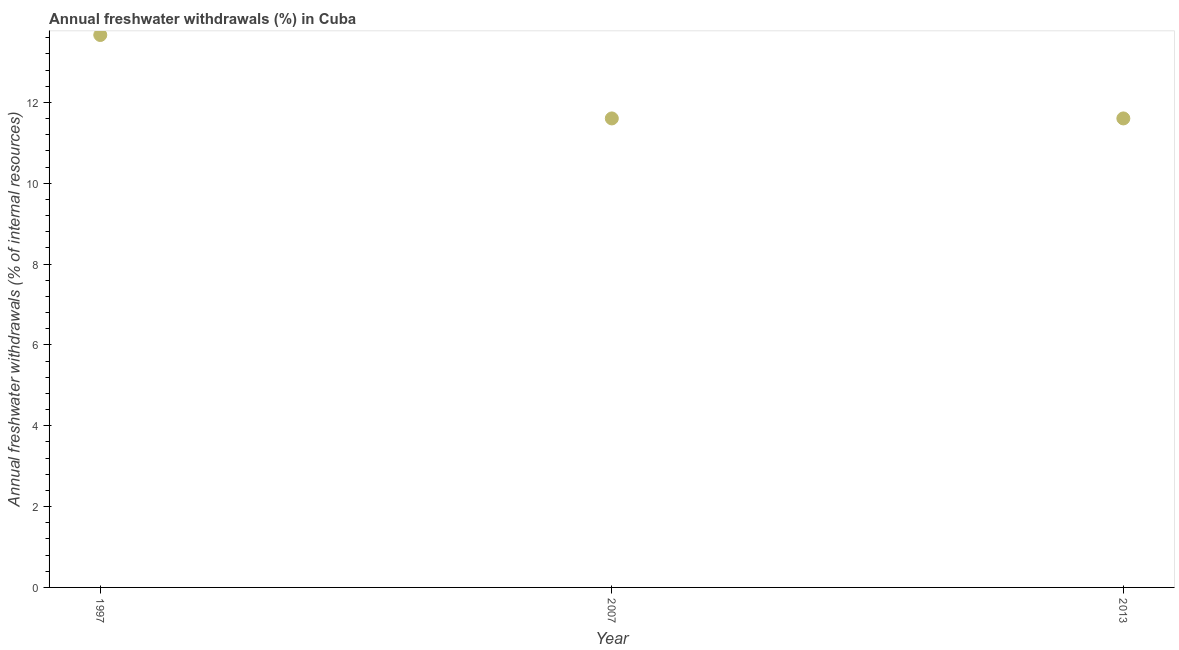What is the annual freshwater withdrawals in 2013?
Your answer should be very brief. 11.61. Across all years, what is the maximum annual freshwater withdrawals?
Give a very brief answer. 13.67. Across all years, what is the minimum annual freshwater withdrawals?
Keep it short and to the point. 11.61. In which year was the annual freshwater withdrawals maximum?
Your answer should be compact. 1997. In which year was the annual freshwater withdrawals minimum?
Provide a short and direct response. 2007. What is the sum of the annual freshwater withdrawals?
Make the answer very short. 36.88. What is the difference between the annual freshwater withdrawals in 2007 and 2013?
Make the answer very short. 0. What is the average annual freshwater withdrawals per year?
Make the answer very short. 12.29. What is the median annual freshwater withdrawals?
Provide a short and direct response. 11.61. Do a majority of the years between 1997 and 2007 (inclusive) have annual freshwater withdrawals greater than 9.6 %?
Make the answer very short. Yes. What is the ratio of the annual freshwater withdrawals in 1997 to that in 2013?
Your response must be concise. 1.18. Is the annual freshwater withdrawals in 1997 less than that in 2007?
Ensure brevity in your answer.  No. Is the difference between the annual freshwater withdrawals in 1997 and 2007 greater than the difference between any two years?
Your answer should be very brief. Yes. What is the difference between the highest and the second highest annual freshwater withdrawals?
Keep it short and to the point. 2.06. What is the difference between the highest and the lowest annual freshwater withdrawals?
Offer a very short reply. 2.06. In how many years, is the annual freshwater withdrawals greater than the average annual freshwater withdrawals taken over all years?
Keep it short and to the point. 1. How many dotlines are there?
Provide a short and direct response. 1. How many years are there in the graph?
Your response must be concise. 3. What is the difference between two consecutive major ticks on the Y-axis?
Ensure brevity in your answer.  2. Are the values on the major ticks of Y-axis written in scientific E-notation?
Keep it short and to the point. No. Does the graph contain any zero values?
Make the answer very short. No. What is the title of the graph?
Make the answer very short. Annual freshwater withdrawals (%) in Cuba. What is the label or title of the X-axis?
Keep it short and to the point. Year. What is the label or title of the Y-axis?
Ensure brevity in your answer.  Annual freshwater withdrawals (% of internal resources). What is the Annual freshwater withdrawals (% of internal resources) in 1997?
Provide a short and direct response. 13.67. What is the Annual freshwater withdrawals (% of internal resources) in 2007?
Give a very brief answer. 11.61. What is the Annual freshwater withdrawals (% of internal resources) in 2013?
Provide a succinct answer. 11.61. What is the difference between the Annual freshwater withdrawals (% of internal resources) in 1997 and 2007?
Provide a short and direct response. 2.06. What is the difference between the Annual freshwater withdrawals (% of internal resources) in 1997 and 2013?
Make the answer very short. 2.06. What is the ratio of the Annual freshwater withdrawals (% of internal resources) in 1997 to that in 2007?
Give a very brief answer. 1.18. What is the ratio of the Annual freshwater withdrawals (% of internal resources) in 1997 to that in 2013?
Provide a short and direct response. 1.18. 